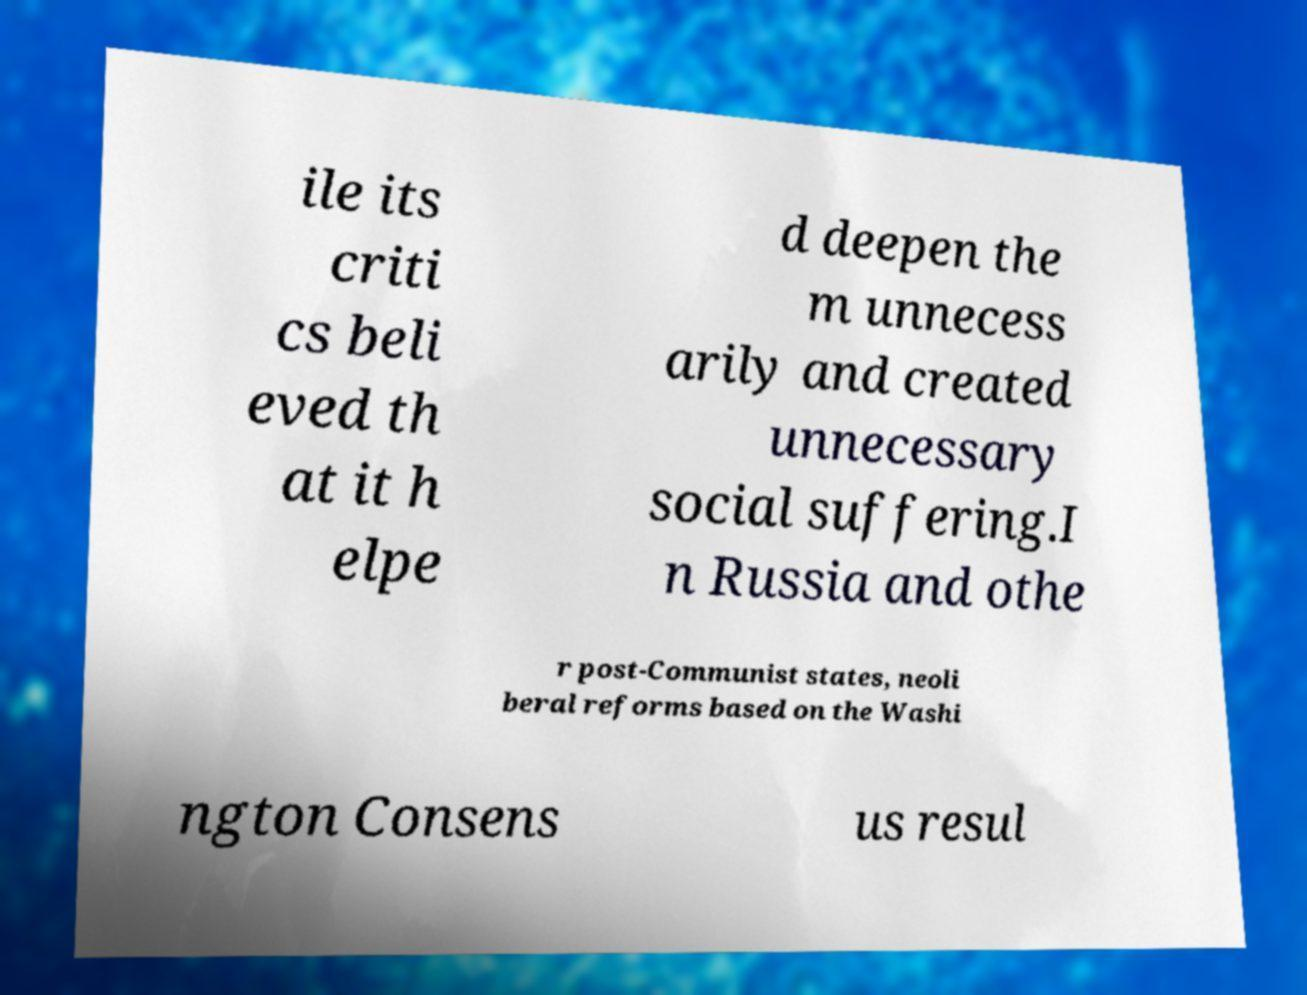Please read and relay the text visible in this image. What does it say? ile its criti cs beli eved th at it h elpe d deepen the m unnecess arily and created unnecessary social suffering.I n Russia and othe r post-Communist states, neoli beral reforms based on the Washi ngton Consens us resul 